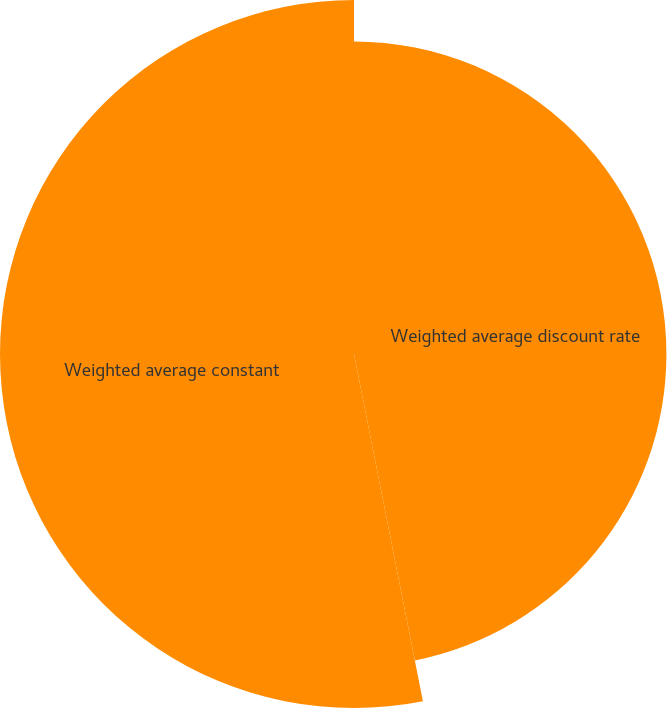<chart> <loc_0><loc_0><loc_500><loc_500><pie_chart><fcel>Weighted average discount rate<fcel>Weighted average constant<nl><fcel>46.88%<fcel>53.12%<nl></chart> 